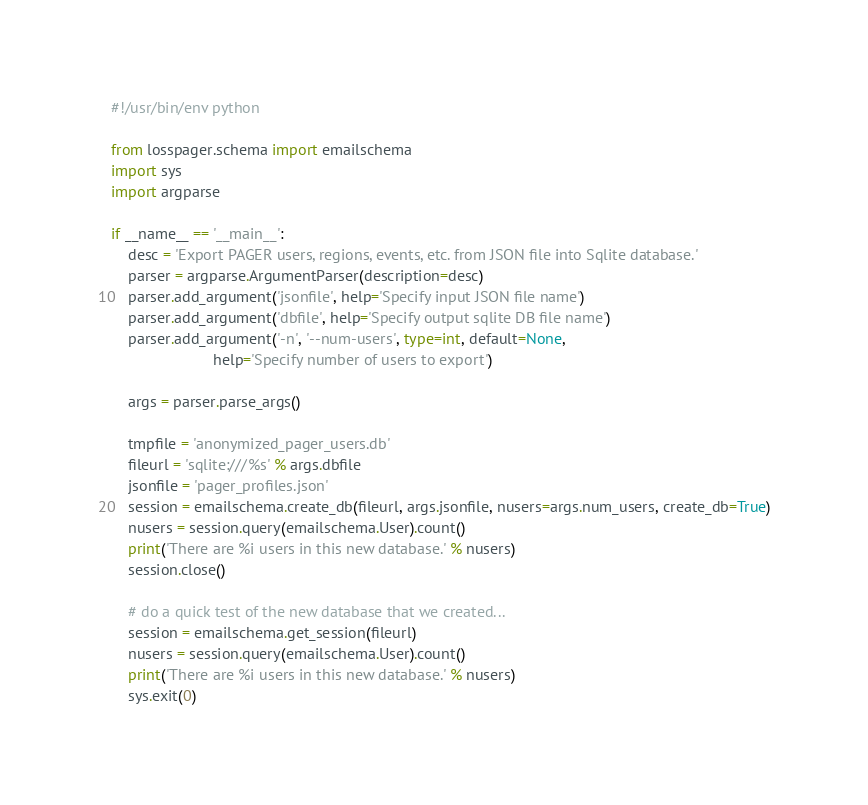Convert code to text. <code><loc_0><loc_0><loc_500><loc_500><_Python_>#!/usr/bin/env python

from losspager.schema import emailschema
import sys
import argparse

if __name__ == '__main__':
    desc = 'Export PAGER users, regions, events, etc. from JSON file into Sqlite database.'
    parser = argparse.ArgumentParser(description=desc)
    parser.add_argument('jsonfile', help='Specify input JSON file name')
    parser.add_argument('dbfile', help='Specify output sqlite DB file name')
    parser.add_argument('-n', '--num-users', type=int, default=None,
                        help='Specify number of users to export')

    args = parser.parse_args()

    tmpfile = 'anonymized_pager_users.db'
    fileurl = 'sqlite:///%s' % args.dbfile
    jsonfile = 'pager_profiles.json'
    session = emailschema.create_db(fileurl, args.jsonfile, nusers=args.num_users, create_db=True)
    nusers = session.query(emailschema.User).count()
    print('There are %i users in this new database.' % nusers)
    session.close()

    # do a quick test of the new database that we created...
    session = emailschema.get_session(fileurl)
    nusers = session.query(emailschema.User).count()
    print('There are %i users in this new database.' % nusers)
    sys.exit(0)


</code> 